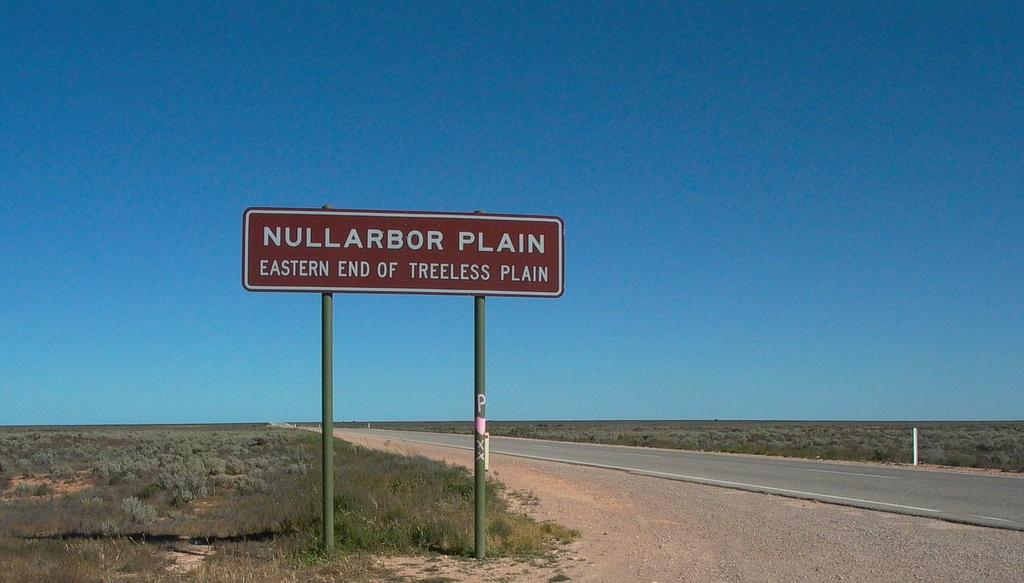<image>
Offer a succinct explanation of the picture presented. A red and white street sign that reads Nullarbor Plain Eastern end of treeles plain. 